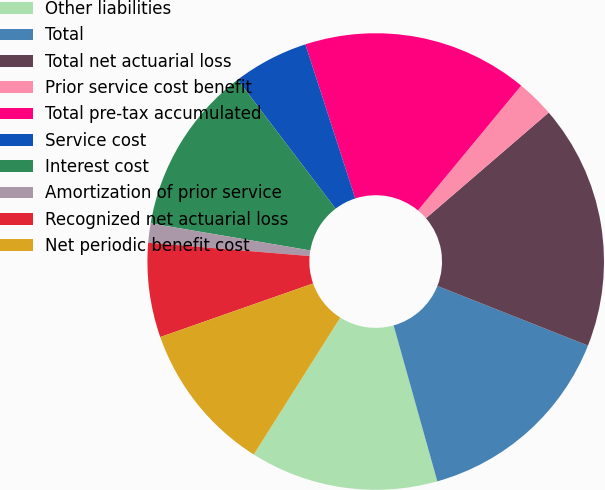<chart> <loc_0><loc_0><loc_500><loc_500><pie_chart><fcel>Other liabilities<fcel>Total<fcel>Total net actuarial loss<fcel>Prior service cost benefit<fcel>Total pre-tax accumulated<fcel>Service cost<fcel>Interest cost<fcel>Amortization of prior service<fcel>Recognized net actuarial loss<fcel>Net periodic benefit cost<nl><fcel>13.32%<fcel>14.65%<fcel>17.31%<fcel>2.69%<fcel>15.98%<fcel>5.35%<fcel>11.99%<fcel>1.36%<fcel>6.68%<fcel>10.66%<nl></chart> 